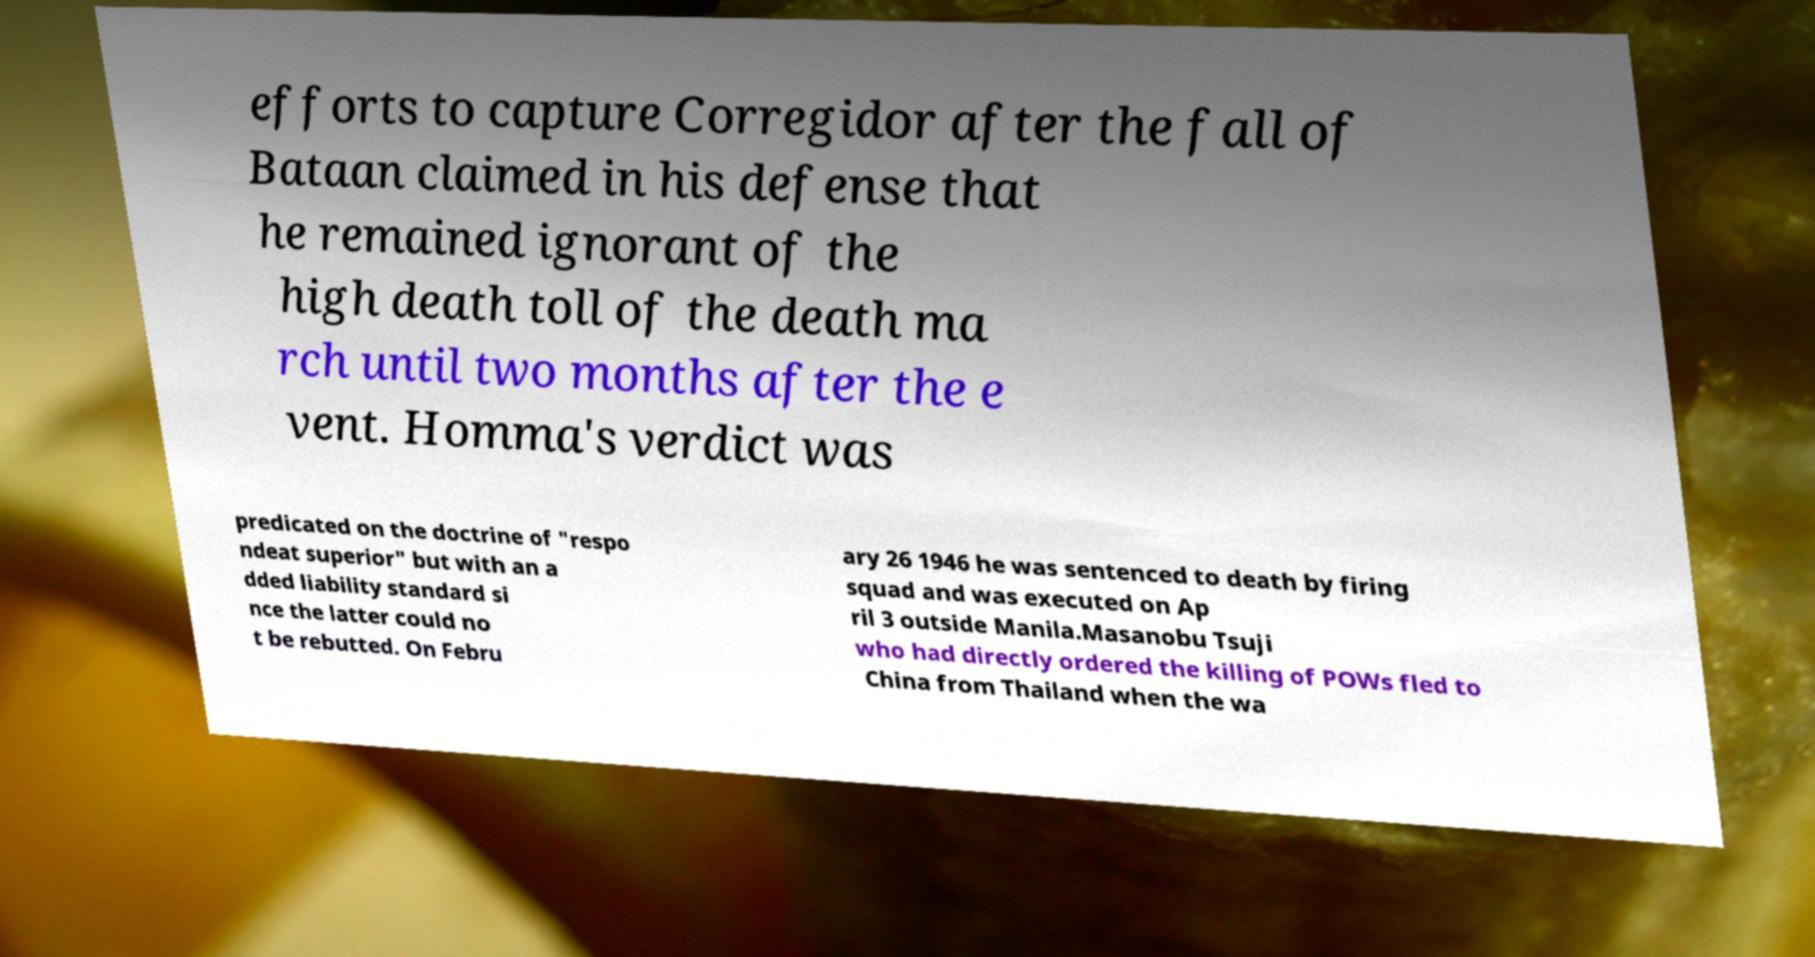Could you assist in decoding the text presented in this image and type it out clearly? efforts to capture Corregidor after the fall of Bataan claimed in his defense that he remained ignorant of the high death toll of the death ma rch until two months after the e vent. Homma's verdict was predicated on the doctrine of "respo ndeat superior" but with an a dded liability standard si nce the latter could no t be rebutted. On Febru ary 26 1946 he was sentenced to death by firing squad and was executed on Ap ril 3 outside Manila.Masanobu Tsuji who had directly ordered the killing of POWs fled to China from Thailand when the wa 